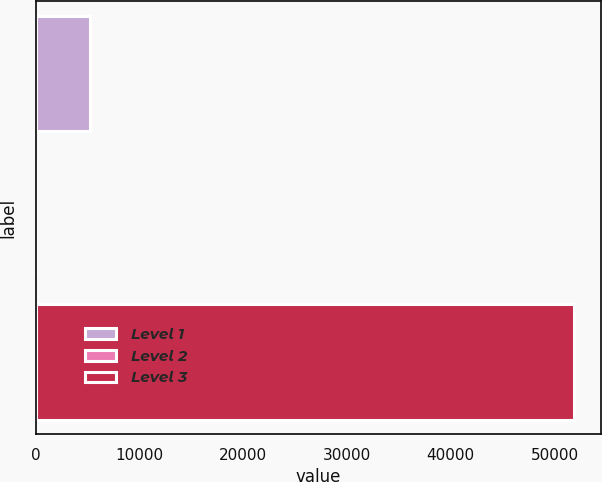Convert chart to OTSL. <chart><loc_0><loc_0><loc_500><loc_500><bar_chart><fcel>Level 1<fcel>Level 2<fcel>Level 3<nl><fcel>5190.97<fcel>2.63<fcel>51886<nl></chart> 